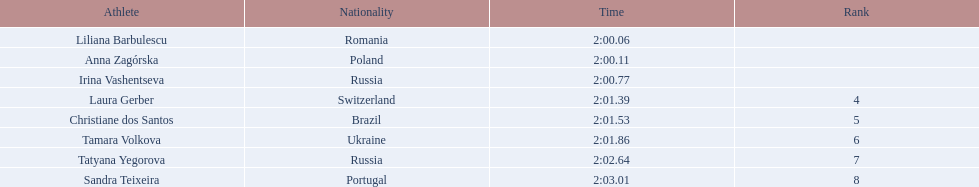Who were the athletes? Liliana Barbulescu, 2:00.06, Anna Zagórska, 2:00.11, Irina Vashentseva, 2:00.77, Laura Gerber, 2:01.39, Christiane dos Santos, 2:01.53, Tamara Volkova, 2:01.86, Tatyana Yegorova, 2:02.64, Sandra Teixeira, 2:03.01. Who received 2nd place? Anna Zagórska, 2:00.11. What was her time? 2:00.11. 